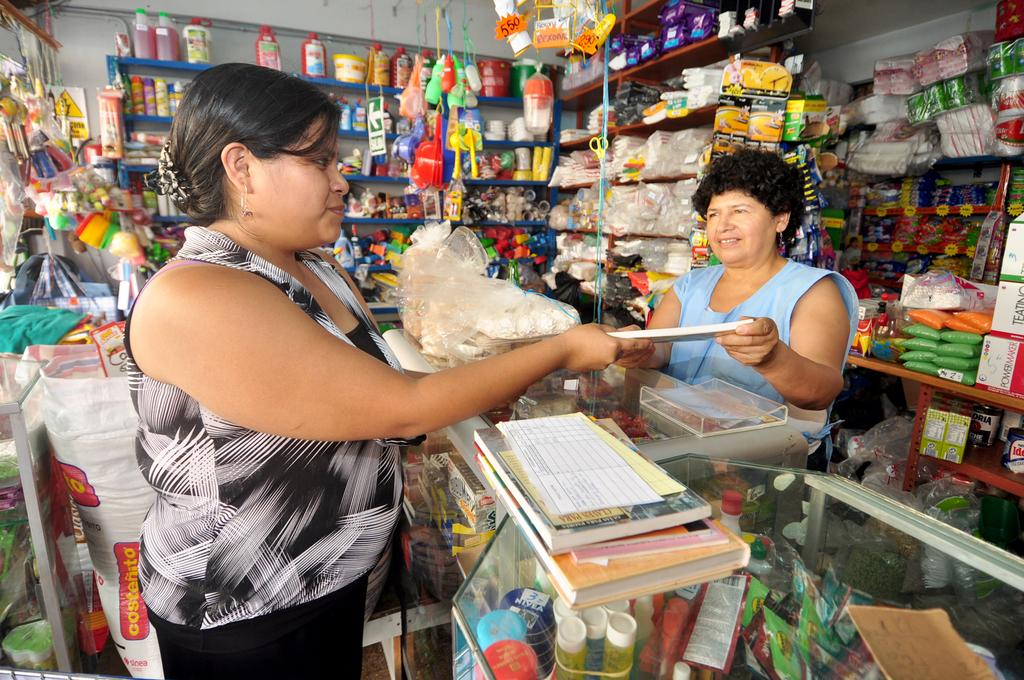<image>
Give a short and clear explanation of the subsequent image. Woman paying in front of a bag of rice named "Costenito". 